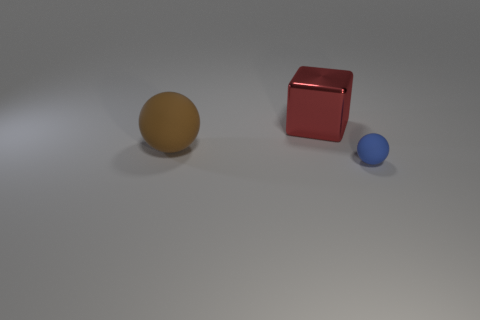Add 2 red shiny things. How many objects exist? 5 Subtract all spheres. How many objects are left? 1 Add 1 yellow matte objects. How many yellow matte objects exist? 1 Subtract 0 gray blocks. How many objects are left? 3 Subtract all large blue cylinders. Subtract all big things. How many objects are left? 1 Add 1 brown things. How many brown things are left? 2 